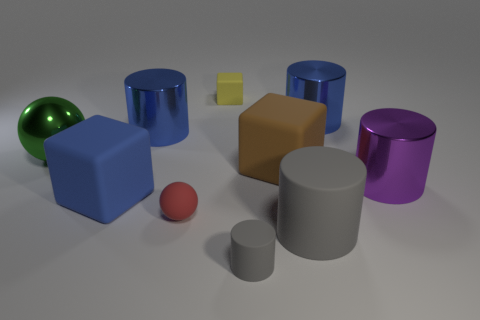Do the green ball and the purple object have the same size?
Provide a succinct answer. Yes. Does the tiny yellow thing have the same shape as the tiny red matte object?
Offer a terse response. No. There is a sphere that is to the left of the blue object that is in front of the large purple object; what color is it?
Provide a short and direct response. Green. What is the color of the matte cylinder that is the same size as the red matte sphere?
Offer a terse response. Gray. How many metallic objects are tiny gray things or red balls?
Offer a very short reply. 0. How many green metallic things are on the left side of the big matte block that is on the left side of the brown matte thing?
Make the answer very short. 1. What is the size of the other cylinder that is the same color as the big rubber cylinder?
Your answer should be very brief. Small. What number of things are either large metal things or large things that are right of the yellow cube?
Your response must be concise. 6. Is there a big gray thing that has the same material as the small block?
Ensure brevity in your answer.  Yes. How many big things are both in front of the big metallic ball and on the left side of the large rubber cylinder?
Make the answer very short. 2. 